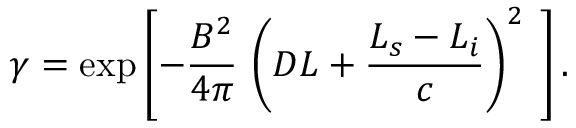<formula> <loc_0><loc_0><loc_500><loc_500>\gamma = \exp \left [ - \frac { B ^ { 2 } } { 4 \pi } \, \left ( D L + \frac { L _ { s } - L _ { i } } { c } \right ) ^ { 2 } { } \right ] .</formula> 